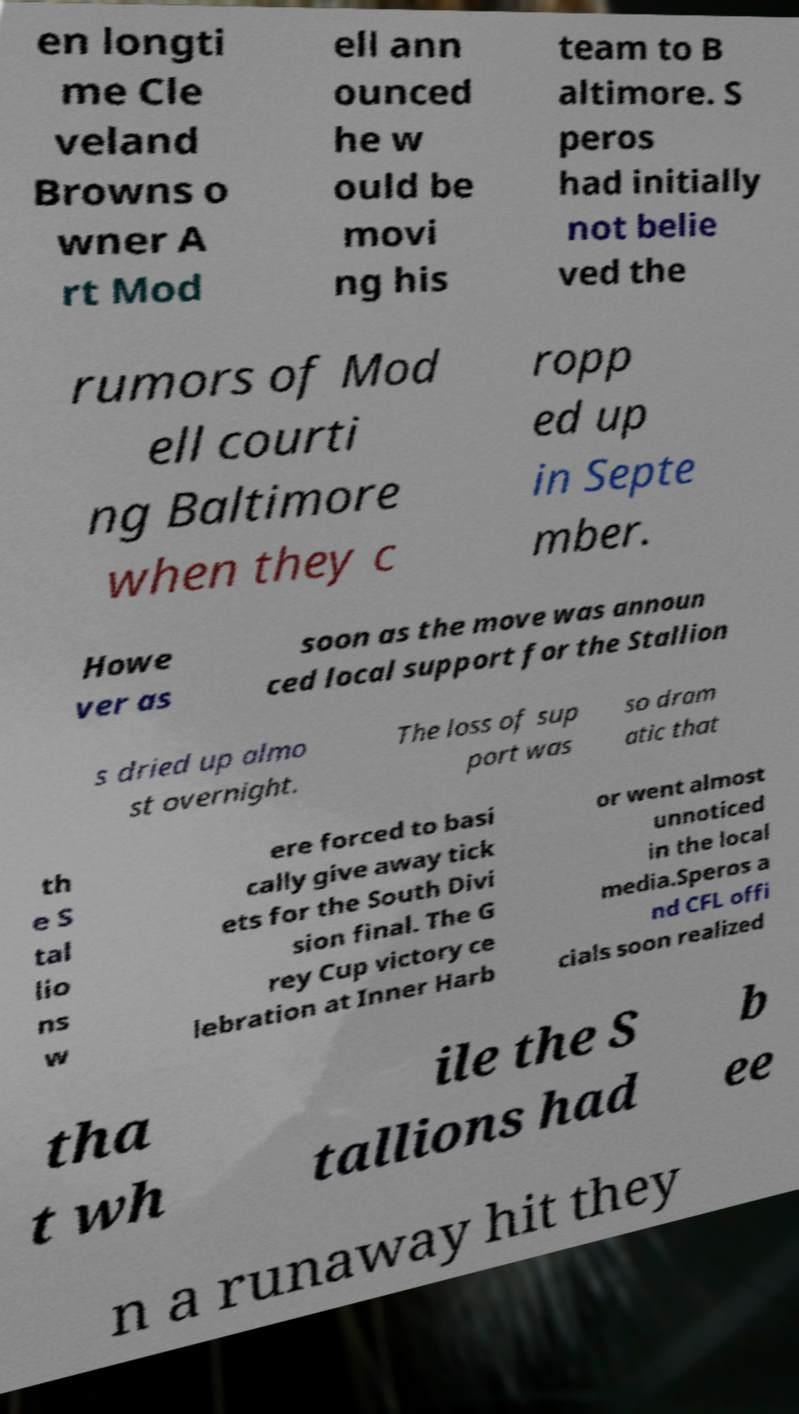What messages or text are displayed in this image? I need them in a readable, typed format. en longti me Cle veland Browns o wner A rt Mod ell ann ounced he w ould be movi ng his team to B altimore. S peros had initially not belie ved the rumors of Mod ell courti ng Baltimore when they c ropp ed up in Septe mber. Howe ver as soon as the move was announ ced local support for the Stallion s dried up almo st overnight. The loss of sup port was so dram atic that th e S tal lio ns w ere forced to basi cally give away tick ets for the South Divi sion final. The G rey Cup victory ce lebration at Inner Harb or went almost unnoticed in the local media.Speros a nd CFL offi cials soon realized tha t wh ile the S tallions had b ee n a runaway hit they 